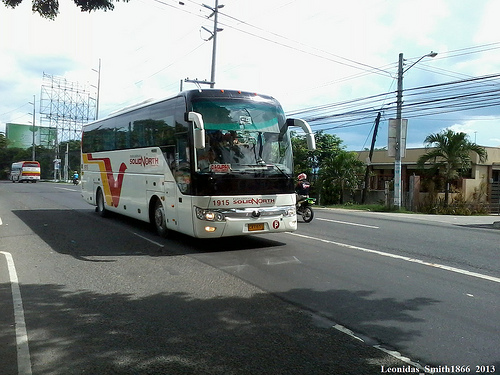Please provide the bounding box coordinate of the region this sentence describes: a wood electrical pole. The bounding box for the region showing a wooden electrical pole should be approximately from (0.74, 0.2) to (0.88, 0.56). 